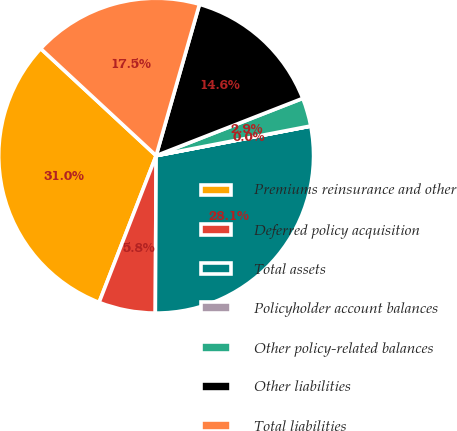Convert chart. <chart><loc_0><loc_0><loc_500><loc_500><pie_chart><fcel>Premiums reinsurance and other<fcel>Deferred policy acquisition<fcel>Total assets<fcel>Policyholder account balances<fcel>Other policy-related balances<fcel>Other liabilities<fcel>Total liabilities<nl><fcel>31.0%<fcel>5.82%<fcel>28.09%<fcel>0.01%<fcel>2.91%<fcel>14.63%<fcel>17.54%<nl></chart> 